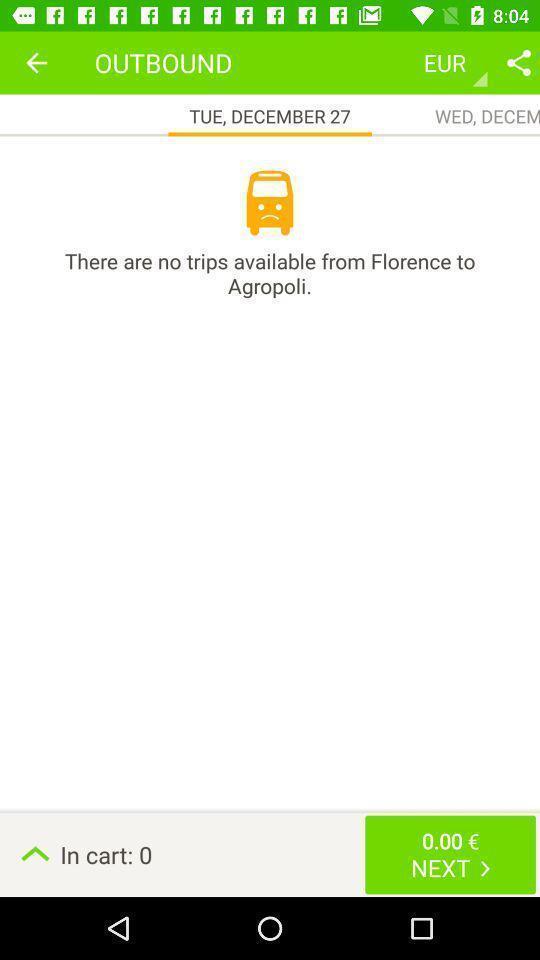Please provide a description for this image. Screen showing no trips available. 